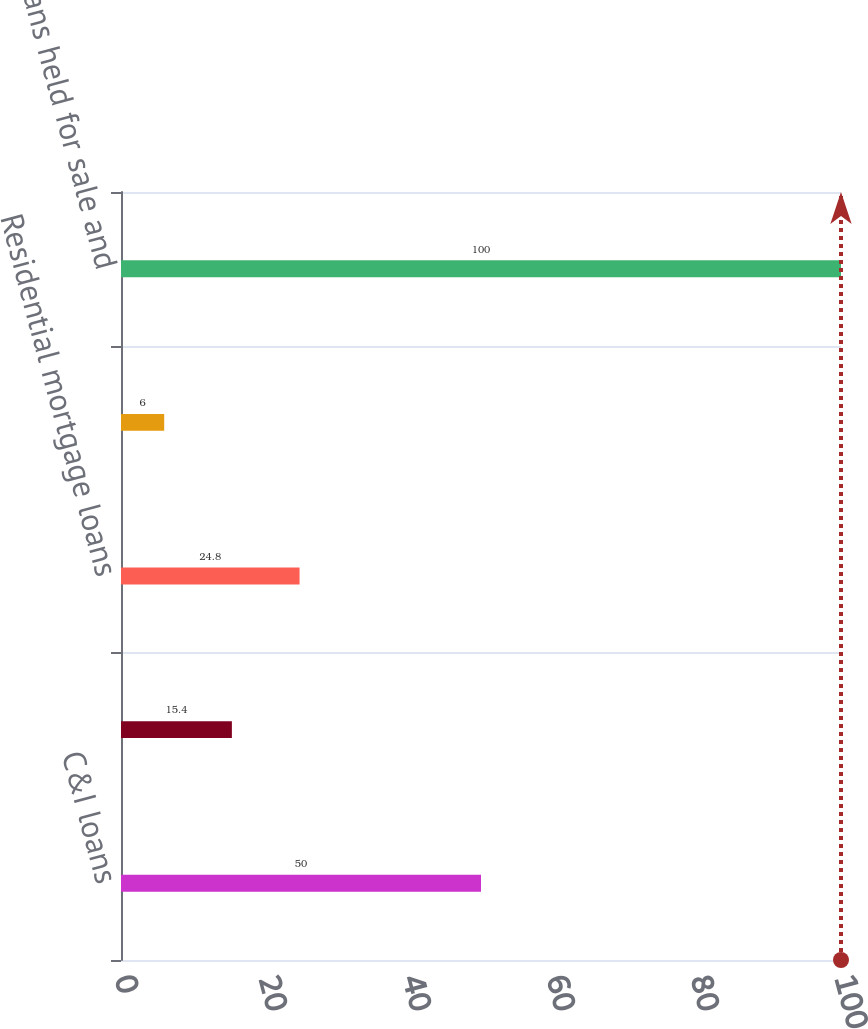Convert chart to OTSL. <chart><loc_0><loc_0><loc_500><loc_500><bar_chart><fcel>C&I loans<fcel>CRE loans<fcel>Residential mortgage loans<fcel>SBL<fcel>Total loans held for sale and<nl><fcel>50<fcel>15.4<fcel>24.8<fcel>6<fcel>100<nl></chart> 